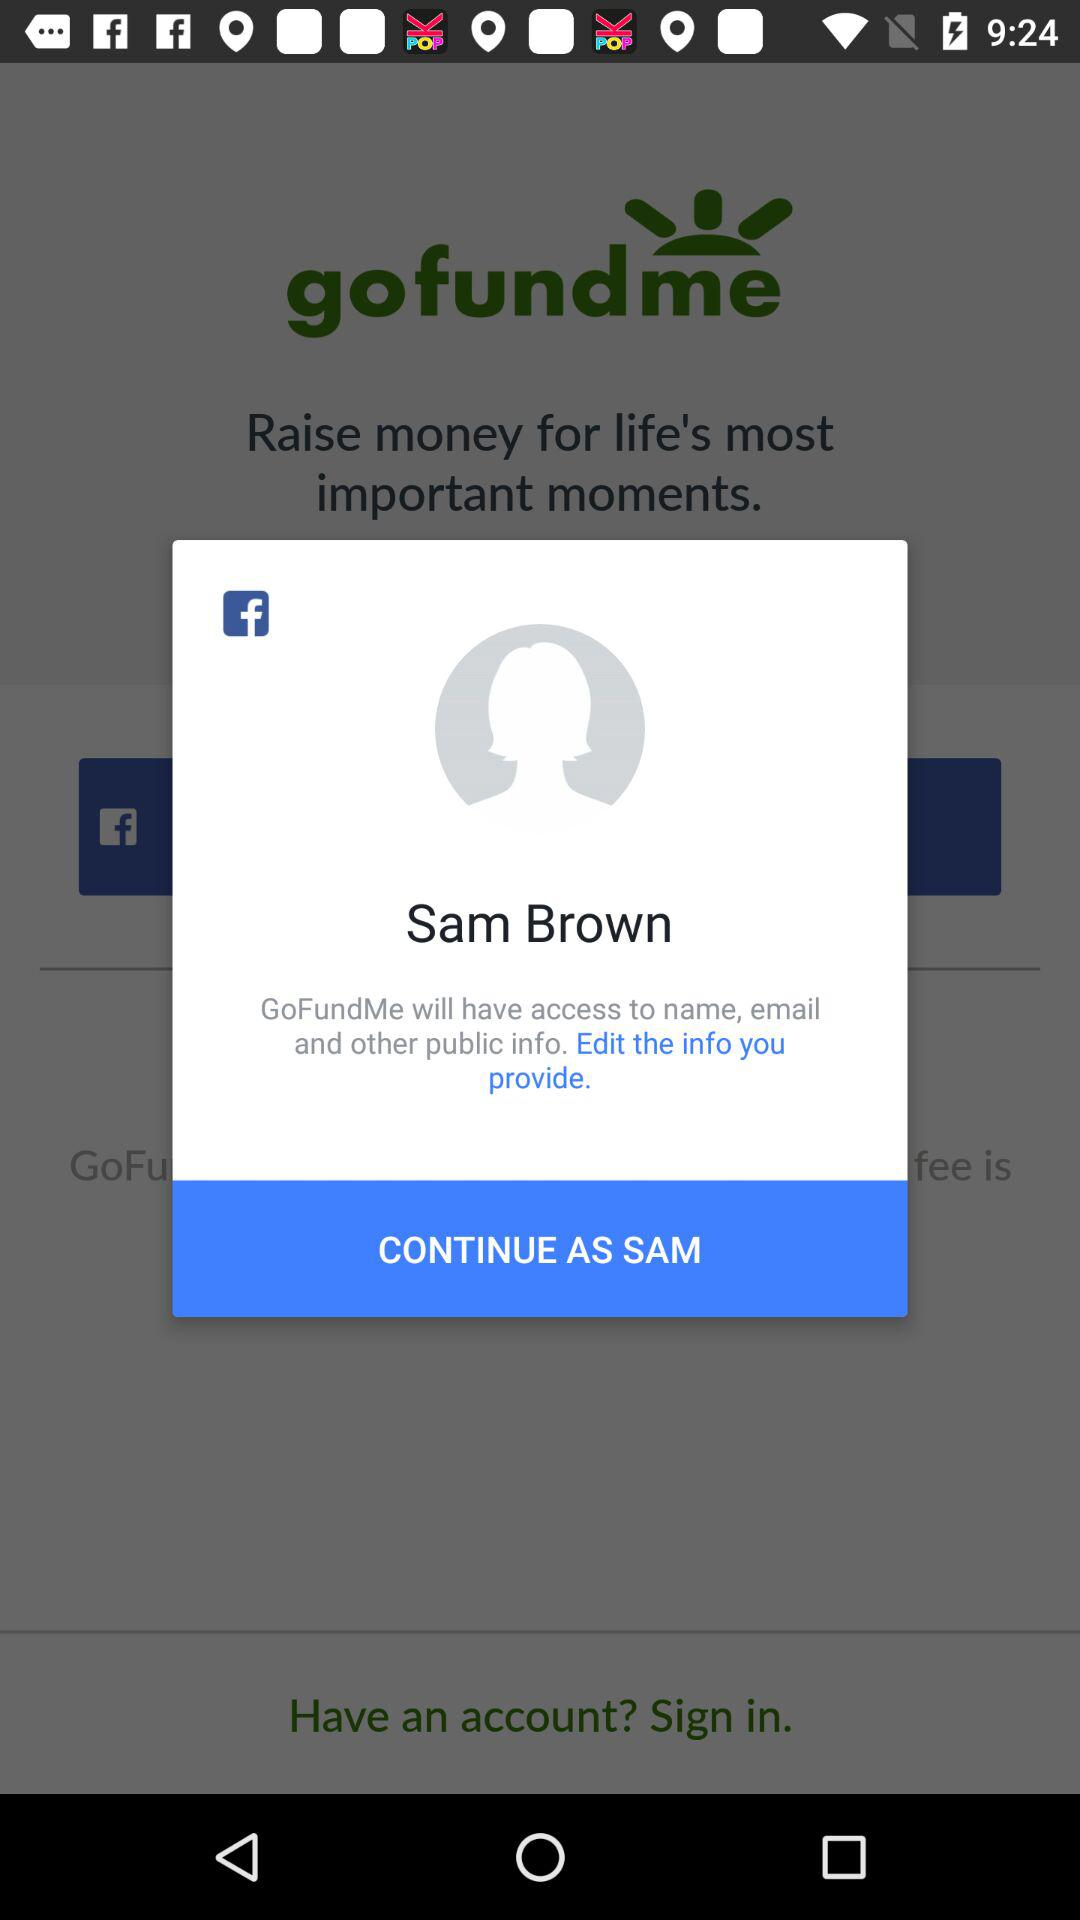What is the name of the user? The name of the user is Sam Brown. 